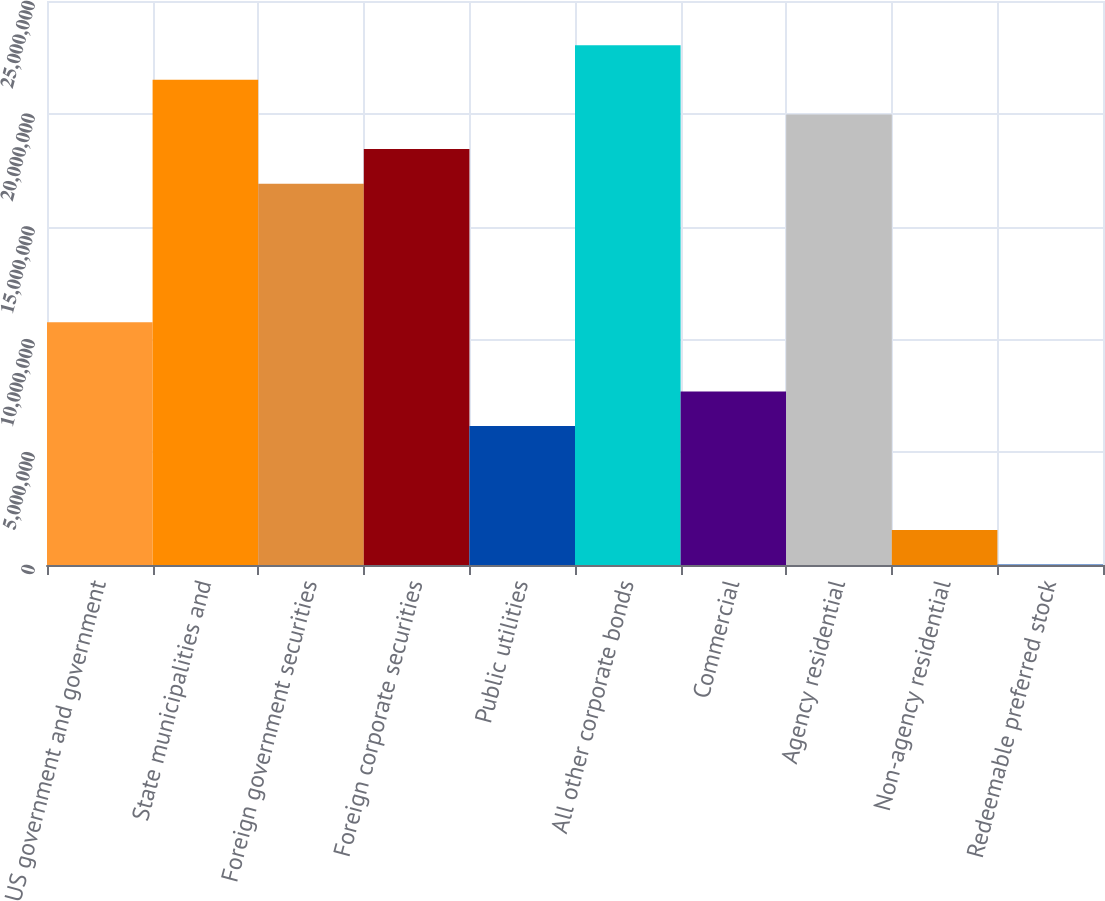<chart> <loc_0><loc_0><loc_500><loc_500><bar_chart><fcel>US government and government<fcel>State municipalities and<fcel>Foreign government securities<fcel>Foreign corporate securities<fcel>Public utilities<fcel>All other corporate bonds<fcel>Commercial<fcel>Agency residential<fcel>Non-agency residential<fcel>Redeemable preferred stock<nl><fcel>1.07608e+07<fcel>2.1504e+07<fcel>1.68998e+07<fcel>1.84345e+07<fcel>6.15657e+06<fcel>2.30387e+07<fcel>7.69131e+06<fcel>1.99692e+07<fcel>1.55234e+06<fcel>17603<nl></chart> 